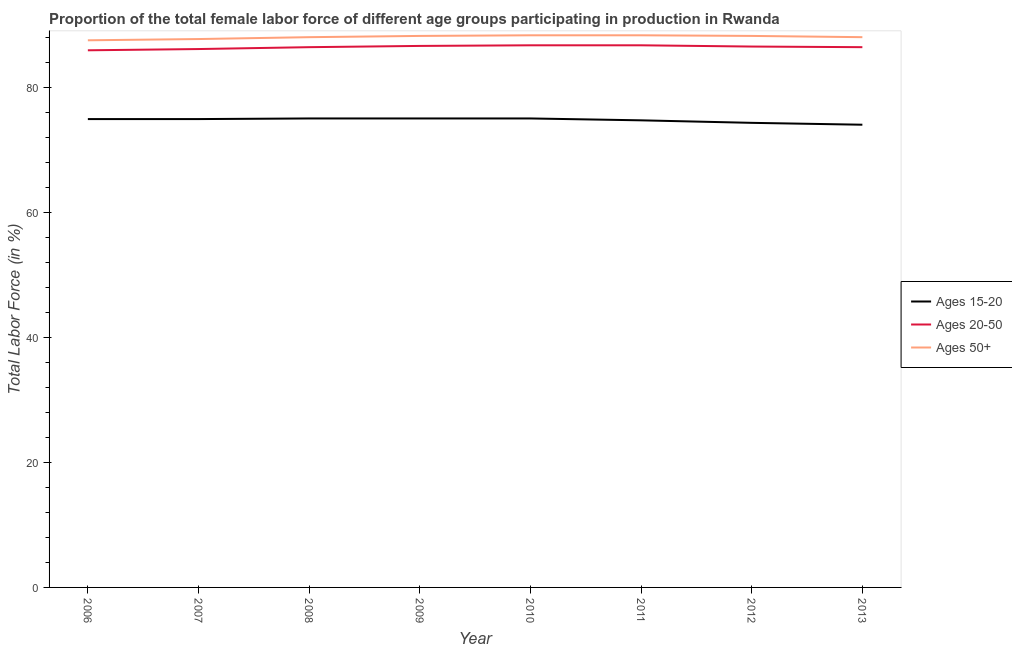Is the number of lines equal to the number of legend labels?
Provide a short and direct response. Yes. What is the percentage of female labor force within the age group 20-50 in 2009?
Ensure brevity in your answer.  86.6. Across all years, what is the maximum percentage of female labor force within the age group 20-50?
Your response must be concise. 86.7. Across all years, what is the minimum percentage of female labor force within the age group 15-20?
Your answer should be very brief. 74. What is the total percentage of female labor force within the age group 15-20 in the graph?
Ensure brevity in your answer.  597.8. What is the difference between the percentage of female labor force above age 50 in 2008 and that in 2011?
Your answer should be very brief. -0.3. What is the difference between the percentage of female labor force above age 50 in 2010 and the percentage of female labor force within the age group 20-50 in 2011?
Provide a succinct answer. 1.6. What is the average percentage of female labor force above age 50 per year?
Provide a succinct answer. 88.02. In the year 2007, what is the difference between the percentage of female labor force within the age group 15-20 and percentage of female labor force within the age group 20-50?
Your response must be concise. -11.2. In how many years, is the percentage of female labor force above age 50 greater than 16 %?
Your answer should be very brief. 8. What is the ratio of the percentage of female labor force above age 50 in 2012 to that in 2013?
Keep it short and to the point. 1. Is the percentage of female labor force within the age group 15-20 in 2006 less than that in 2012?
Provide a succinct answer. No. What is the difference between the highest and the second highest percentage of female labor force within the age group 15-20?
Your answer should be very brief. 0. What is the difference between the highest and the lowest percentage of female labor force within the age group 15-20?
Your answer should be compact. 1. Is it the case that in every year, the sum of the percentage of female labor force within the age group 15-20 and percentage of female labor force within the age group 20-50 is greater than the percentage of female labor force above age 50?
Provide a short and direct response. Yes. Is the percentage of female labor force within the age group 20-50 strictly greater than the percentage of female labor force within the age group 15-20 over the years?
Your response must be concise. Yes. How many years are there in the graph?
Make the answer very short. 8. Does the graph contain any zero values?
Offer a very short reply. No. Does the graph contain grids?
Ensure brevity in your answer.  No. Where does the legend appear in the graph?
Offer a terse response. Center right. How many legend labels are there?
Offer a terse response. 3. How are the legend labels stacked?
Provide a succinct answer. Vertical. What is the title of the graph?
Give a very brief answer. Proportion of the total female labor force of different age groups participating in production in Rwanda. What is the label or title of the X-axis?
Make the answer very short. Year. What is the label or title of the Y-axis?
Your response must be concise. Total Labor Force (in %). What is the Total Labor Force (in %) of Ages 15-20 in 2006?
Your answer should be very brief. 74.9. What is the Total Labor Force (in %) of Ages 20-50 in 2006?
Ensure brevity in your answer.  85.9. What is the Total Labor Force (in %) of Ages 50+ in 2006?
Keep it short and to the point. 87.5. What is the Total Labor Force (in %) in Ages 15-20 in 2007?
Ensure brevity in your answer.  74.9. What is the Total Labor Force (in %) of Ages 20-50 in 2007?
Ensure brevity in your answer.  86.1. What is the Total Labor Force (in %) of Ages 50+ in 2007?
Provide a short and direct response. 87.7. What is the Total Labor Force (in %) in Ages 15-20 in 2008?
Offer a terse response. 75. What is the Total Labor Force (in %) in Ages 20-50 in 2008?
Keep it short and to the point. 86.4. What is the Total Labor Force (in %) in Ages 20-50 in 2009?
Keep it short and to the point. 86.6. What is the Total Labor Force (in %) of Ages 50+ in 2009?
Keep it short and to the point. 88.2. What is the Total Labor Force (in %) in Ages 20-50 in 2010?
Offer a very short reply. 86.7. What is the Total Labor Force (in %) in Ages 50+ in 2010?
Give a very brief answer. 88.3. What is the Total Labor Force (in %) in Ages 15-20 in 2011?
Make the answer very short. 74.7. What is the Total Labor Force (in %) in Ages 20-50 in 2011?
Offer a very short reply. 86.7. What is the Total Labor Force (in %) in Ages 50+ in 2011?
Provide a short and direct response. 88.3. What is the Total Labor Force (in %) of Ages 15-20 in 2012?
Offer a terse response. 74.3. What is the Total Labor Force (in %) of Ages 20-50 in 2012?
Provide a succinct answer. 86.5. What is the Total Labor Force (in %) of Ages 50+ in 2012?
Keep it short and to the point. 88.2. What is the Total Labor Force (in %) in Ages 15-20 in 2013?
Provide a succinct answer. 74. What is the Total Labor Force (in %) of Ages 20-50 in 2013?
Offer a very short reply. 86.4. What is the Total Labor Force (in %) in Ages 50+ in 2013?
Provide a short and direct response. 88. Across all years, what is the maximum Total Labor Force (in %) in Ages 20-50?
Offer a terse response. 86.7. Across all years, what is the maximum Total Labor Force (in %) of Ages 50+?
Give a very brief answer. 88.3. Across all years, what is the minimum Total Labor Force (in %) in Ages 15-20?
Offer a very short reply. 74. Across all years, what is the minimum Total Labor Force (in %) of Ages 20-50?
Your response must be concise. 85.9. Across all years, what is the minimum Total Labor Force (in %) in Ages 50+?
Provide a short and direct response. 87.5. What is the total Total Labor Force (in %) in Ages 15-20 in the graph?
Provide a succinct answer. 597.8. What is the total Total Labor Force (in %) in Ages 20-50 in the graph?
Ensure brevity in your answer.  691.3. What is the total Total Labor Force (in %) of Ages 50+ in the graph?
Keep it short and to the point. 704.2. What is the difference between the Total Labor Force (in %) in Ages 15-20 in 2006 and that in 2009?
Make the answer very short. -0.1. What is the difference between the Total Labor Force (in %) in Ages 50+ in 2006 and that in 2009?
Offer a very short reply. -0.7. What is the difference between the Total Labor Force (in %) in Ages 20-50 in 2006 and that in 2010?
Offer a very short reply. -0.8. What is the difference between the Total Labor Force (in %) in Ages 50+ in 2006 and that in 2010?
Keep it short and to the point. -0.8. What is the difference between the Total Labor Force (in %) of Ages 50+ in 2006 and that in 2011?
Offer a very short reply. -0.8. What is the difference between the Total Labor Force (in %) in Ages 50+ in 2006 and that in 2012?
Your response must be concise. -0.7. What is the difference between the Total Labor Force (in %) of Ages 20-50 in 2006 and that in 2013?
Your answer should be compact. -0.5. What is the difference between the Total Labor Force (in %) in Ages 50+ in 2006 and that in 2013?
Give a very brief answer. -0.5. What is the difference between the Total Labor Force (in %) in Ages 20-50 in 2007 and that in 2008?
Offer a very short reply. -0.3. What is the difference between the Total Labor Force (in %) in Ages 50+ in 2007 and that in 2008?
Your response must be concise. -0.3. What is the difference between the Total Labor Force (in %) of Ages 20-50 in 2007 and that in 2009?
Make the answer very short. -0.5. What is the difference between the Total Labor Force (in %) in Ages 50+ in 2007 and that in 2009?
Your answer should be compact. -0.5. What is the difference between the Total Labor Force (in %) in Ages 15-20 in 2007 and that in 2010?
Your response must be concise. -0.1. What is the difference between the Total Labor Force (in %) in Ages 50+ in 2007 and that in 2010?
Give a very brief answer. -0.6. What is the difference between the Total Labor Force (in %) of Ages 15-20 in 2007 and that in 2011?
Your answer should be very brief. 0.2. What is the difference between the Total Labor Force (in %) in Ages 50+ in 2007 and that in 2011?
Offer a terse response. -0.6. What is the difference between the Total Labor Force (in %) in Ages 15-20 in 2007 and that in 2012?
Ensure brevity in your answer.  0.6. What is the difference between the Total Labor Force (in %) of Ages 50+ in 2007 and that in 2012?
Make the answer very short. -0.5. What is the difference between the Total Labor Force (in %) in Ages 15-20 in 2007 and that in 2013?
Give a very brief answer. 0.9. What is the difference between the Total Labor Force (in %) of Ages 15-20 in 2008 and that in 2009?
Make the answer very short. 0. What is the difference between the Total Labor Force (in %) in Ages 20-50 in 2008 and that in 2009?
Your response must be concise. -0.2. What is the difference between the Total Labor Force (in %) of Ages 50+ in 2008 and that in 2009?
Your answer should be compact. -0.2. What is the difference between the Total Labor Force (in %) in Ages 20-50 in 2008 and that in 2010?
Your answer should be compact. -0.3. What is the difference between the Total Labor Force (in %) in Ages 50+ in 2008 and that in 2010?
Ensure brevity in your answer.  -0.3. What is the difference between the Total Labor Force (in %) in Ages 15-20 in 2008 and that in 2011?
Ensure brevity in your answer.  0.3. What is the difference between the Total Labor Force (in %) in Ages 20-50 in 2008 and that in 2011?
Offer a terse response. -0.3. What is the difference between the Total Labor Force (in %) of Ages 15-20 in 2008 and that in 2012?
Keep it short and to the point. 0.7. What is the difference between the Total Labor Force (in %) in Ages 15-20 in 2008 and that in 2013?
Provide a short and direct response. 1. What is the difference between the Total Labor Force (in %) in Ages 15-20 in 2009 and that in 2010?
Your answer should be very brief. 0. What is the difference between the Total Labor Force (in %) of Ages 50+ in 2009 and that in 2010?
Provide a succinct answer. -0.1. What is the difference between the Total Labor Force (in %) of Ages 50+ in 2009 and that in 2011?
Give a very brief answer. -0.1. What is the difference between the Total Labor Force (in %) of Ages 15-20 in 2009 and that in 2012?
Your response must be concise. 0.7. What is the difference between the Total Labor Force (in %) in Ages 50+ in 2009 and that in 2013?
Offer a very short reply. 0.2. What is the difference between the Total Labor Force (in %) of Ages 15-20 in 2010 and that in 2011?
Your answer should be compact. 0.3. What is the difference between the Total Labor Force (in %) of Ages 50+ in 2010 and that in 2011?
Your answer should be very brief. 0. What is the difference between the Total Labor Force (in %) of Ages 15-20 in 2010 and that in 2012?
Your answer should be very brief. 0.7. What is the difference between the Total Labor Force (in %) in Ages 20-50 in 2010 and that in 2012?
Give a very brief answer. 0.2. What is the difference between the Total Labor Force (in %) in Ages 50+ in 2010 and that in 2012?
Your answer should be compact. 0.1. What is the difference between the Total Labor Force (in %) of Ages 15-20 in 2010 and that in 2013?
Ensure brevity in your answer.  1. What is the difference between the Total Labor Force (in %) of Ages 50+ in 2010 and that in 2013?
Provide a short and direct response. 0.3. What is the difference between the Total Labor Force (in %) of Ages 15-20 in 2011 and that in 2012?
Give a very brief answer. 0.4. What is the difference between the Total Labor Force (in %) of Ages 20-50 in 2011 and that in 2012?
Make the answer very short. 0.2. What is the difference between the Total Labor Force (in %) of Ages 50+ in 2011 and that in 2012?
Give a very brief answer. 0.1. What is the difference between the Total Labor Force (in %) of Ages 20-50 in 2011 and that in 2013?
Provide a succinct answer. 0.3. What is the difference between the Total Labor Force (in %) in Ages 50+ in 2012 and that in 2013?
Your response must be concise. 0.2. What is the difference between the Total Labor Force (in %) of Ages 15-20 in 2006 and the Total Labor Force (in %) of Ages 20-50 in 2008?
Your answer should be compact. -11.5. What is the difference between the Total Labor Force (in %) in Ages 20-50 in 2006 and the Total Labor Force (in %) in Ages 50+ in 2010?
Your answer should be very brief. -2.4. What is the difference between the Total Labor Force (in %) in Ages 15-20 in 2006 and the Total Labor Force (in %) in Ages 50+ in 2011?
Make the answer very short. -13.4. What is the difference between the Total Labor Force (in %) in Ages 15-20 in 2006 and the Total Labor Force (in %) in Ages 20-50 in 2012?
Your response must be concise. -11.6. What is the difference between the Total Labor Force (in %) of Ages 20-50 in 2006 and the Total Labor Force (in %) of Ages 50+ in 2012?
Offer a terse response. -2.3. What is the difference between the Total Labor Force (in %) of Ages 15-20 in 2006 and the Total Labor Force (in %) of Ages 20-50 in 2013?
Provide a short and direct response. -11.5. What is the difference between the Total Labor Force (in %) of Ages 20-50 in 2006 and the Total Labor Force (in %) of Ages 50+ in 2013?
Keep it short and to the point. -2.1. What is the difference between the Total Labor Force (in %) in Ages 15-20 in 2007 and the Total Labor Force (in %) in Ages 20-50 in 2008?
Provide a short and direct response. -11.5. What is the difference between the Total Labor Force (in %) of Ages 15-20 in 2007 and the Total Labor Force (in %) of Ages 50+ in 2008?
Offer a terse response. -13.1. What is the difference between the Total Labor Force (in %) of Ages 20-50 in 2007 and the Total Labor Force (in %) of Ages 50+ in 2008?
Ensure brevity in your answer.  -1.9. What is the difference between the Total Labor Force (in %) in Ages 15-20 in 2007 and the Total Labor Force (in %) in Ages 20-50 in 2009?
Your answer should be compact. -11.7. What is the difference between the Total Labor Force (in %) in Ages 15-20 in 2007 and the Total Labor Force (in %) in Ages 50+ in 2009?
Offer a very short reply. -13.3. What is the difference between the Total Labor Force (in %) in Ages 15-20 in 2007 and the Total Labor Force (in %) in Ages 20-50 in 2011?
Provide a succinct answer. -11.8. What is the difference between the Total Labor Force (in %) of Ages 15-20 in 2007 and the Total Labor Force (in %) of Ages 50+ in 2011?
Your answer should be compact. -13.4. What is the difference between the Total Labor Force (in %) of Ages 15-20 in 2007 and the Total Labor Force (in %) of Ages 20-50 in 2012?
Your answer should be compact. -11.6. What is the difference between the Total Labor Force (in %) in Ages 15-20 in 2007 and the Total Labor Force (in %) in Ages 50+ in 2013?
Offer a terse response. -13.1. What is the difference between the Total Labor Force (in %) in Ages 15-20 in 2008 and the Total Labor Force (in %) in Ages 50+ in 2009?
Keep it short and to the point. -13.2. What is the difference between the Total Labor Force (in %) of Ages 20-50 in 2008 and the Total Labor Force (in %) of Ages 50+ in 2009?
Your answer should be compact. -1.8. What is the difference between the Total Labor Force (in %) in Ages 15-20 in 2008 and the Total Labor Force (in %) in Ages 20-50 in 2010?
Your response must be concise. -11.7. What is the difference between the Total Labor Force (in %) in Ages 15-20 in 2008 and the Total Labor Force (in %) in Ages 50+ in 2011?
Keep it short and to the point. -13.3. What is the difference between the Total Labor Force (in %) of Ages 20-50 in 2008 and the Total Labor Force (in %) of Ages 50+ in 2011?
Make the answer very short. -1.9. What is the difference between the Total Labor Force (in %) in Ages 15-20 in 2008 and the Total Labor Force (in %) in Ages 20-50 in 2012?
Your response must be concise. -11.5. What is the difference between the Total Labor Force (in %) in Ages 20-50 in 2008 and the Total Labor Force (in %) in Ages 50+ in 2013?
Keep it short and to the point. -1.6. What is the difference between the Total Labor Force (in %) of Ages 15-20 in 2009 and the Total Labor Force (in %) of Ages 50+ in 2010?
Provide a succinct answer. -13.3. What is the difference between the Total Labor Force (in %) of Ages 15-20 in 2009 and the Total Labor Force (in %) of Ages 20-50 in 2011?
Provide a short and direct response. -11.7. What is the difference between the Total Labor Force (in %) of Ages 20-50 in 2009 and the Total Labor Force (in %) of Ages 50+ in 2011?
Your answer should be compact. -1.7. What is the difference between the Total Labor Force (in %) of Ages 20-50 in 2009 and the Total Labor Force (in %) of Ages 50+ in 2012?
Give a very brief answer. -1.6. What is the difference between the Total Labor Force (in %) of Ages 15-20 in 2009 and the Total Labor Force (in %) of Ages 50+ in 2013?
Make the answer very short. -13. What is the difference between the Total Labor Force (in %) of Ages 15-20 in 2010 and the Total Labor Force (in %) of Ages 50+ in 2011?
Your answer should be compact. -13.3. What is the difference between the Total Labor Force (in %) of Ages 15-20 in 2010 and the Total Labor Force (in %) of Ages 20-50 in 2012?
Keep it short and to the point. -11.5. What is the difference between the Total Labor Force (in %) of Ages 15-20 in 2010 and the Total Labor Force (in %) of Ages 50+ in 2013?
Make the answer very short. -13. What is the difference between the Total Labor Force (in %) in Ages 15-20 in 2011 and the Total Labor Force (in %) in Ages 50+ in 2012?
Make the answer very short. -13.5. What is the difference between the Total Labor Force (in %) of Ages 20-50 in 2011 and the Total Labor Force (in %) of Ages 50+ in 2012?
Offer a very short reply. -1.5. What is the difference between the Total Labor Force (in %) of Ages 15-20 in 2011 and the Total Labor Force (in %) of Ages 20-50 in 2013?
Give a very brief answer. -11.7. What is the difference between the Total Labor Force (in %) of Ages 15-20 in 2012 and the Total Labor Force (in %) of Ages 50+ in 2013?
Provide a succinct answer. -13.7. What is the difference between the Total Labor Force (in %) of Ages 20-50 in 2012 and the Total Labor Force (in %) of Ages 50+ in 2013?
Your response must be concise. -1.5. What is the average Total Labor Force (in %) in Ages 15-20 per year?
Give a very brief answer. 74.72. What is the average Total Labor Force (in %) in Ages 20-50 per year?
Give a very brief answer. 86.41. What is the average Total Labor Force (in %) of Ages 50+ per year?
Make the answer very short. 88.03. In the year 2006, what is the difference between the Total Labor Force (in %) in Ages 15-20 and Total Labor Force (in %) in Ages 50+?
Keep it short and to the point. -12.6. In the year 2008, what is the difference between the Total Labor Force (in %) in Ages 20-50 and Total Labor Force (in %) in Ages 50+?
Provide a short and direct response. -1.6. In the year 2009, what is the difference between the Total Labor Force (in %) in Ages 15-20 and Total Labor Force (in %) in Ages 20-50?
Your answer should be compact. -11.6. In the year 2009, what is the difference between the Total Labor Force (in %) of Ages 15-20 and Total Labor Force (in %) of Ages 50+?
Make the answer very short. -13.2. In the year 2010, what is the difference between the Total Labor Force (in %) in Ages 15-20 and Total Labor Force (in %) in Ages 20-50?
Your answer should be very brief. -11.7. In the year 2010, what is the difference between the Total Labor Force (in %) of Ages 20-50 and Total Labor Force (in %) of Ages 50+?
Give a very brief answer. -1.6. In the year 2011, what is the difference between the Total Labor Force (in %) of Ages 20-50 and Total Labor Force (in %) of Ages 50+?
Make the answer very short. -1.6. In the year 2012, what is the difference between the Total Labor Force (in %) in Ages 15-20 and Total Labor Force (in %) in Ages 50+?
Provide a succinct answer. -13.9. In the year 2012, what is the difference between the Total Labor Force (in %) of Ages 20-50 and Total Labor Force (in %) of Ages 50+?
Ensure brevity in your answer.  -1.7. In the year 2013, what is the difference between the Total Labor Force (in %) of Ages 20-50 and Total Labor Force (in %) of Ages 50+?
Offer a very short reply. -1.6. What is the ratio of the Total Labor Force (in %) of Ages 20-50 in 2006 to that in 2007?
Provide a short and direct response. 1. What is the ratio of the Total Labor Force (in %) in Ages 50+ in 2006 to that in 2007?
Your response must be concise. 1. What is the ratio of the Total Labor Force (in %) in Ages 50+ in 2006 to that in 2008?
Ensure brevity in your answer.  0.99. What is the ratio of the Total Labor Force (in %) of Ages 20-50 in 2006 to that in 2009?
Provide a succinct answer. 0.99. What is the ratio of the Total Labor Force (in %) of Ages 50+ in 2006 to that in 2010?
Offer a very short reply. 0.99. What is the ratio of the Total Labor Force (in %) of Ages 20-50 in 2006 to that in 2011?
Your answer should be very brief. 0.99. What is the ratio of the Total Labor Force (in %) in Ages 50+ in 2006 to that in 2011?
Your response must be concise. 0.99. What is the ratio of the Total Labor Force (in %) of Ages 20-50 in 2006 to that in 2012?
Offer a very short reply. 0.99. What is the ratio of the Total Labor Force (in %) in Ages 15-20 in 2006 to that in 2013?
Your response must be concise. 1.01. What is the ratio of the Total Labor Force (in %) of Ages 20-50 in 2006 to that in 2013?
Ensure brevity in your answer.  0.99. What is the ratio of the Total Labor Force (in %) of Ages 50+ in 2006 to that in 2013?
Your answer should be compact. 0.99. What is the ratio of the Total Labor Force (in %) in Ages 15-20 in 2007 to that in 2008?
Your answer should be very brief. 1. What is the ratio of the Total Labor Force (in %) in Ages 20-50 in 2007 to that in 2008?
Offer a very short reply. 1. What is the ratio of the Total Labor Force (in %) in Ages 20-50 in 2007 to that in 2010?
Offer a terse response. 0.99. What is the ratio of the Total Labor Force (in %) in Ages 15-20 in 2007 to that in 2011?
Provide a succinct answer. 1. What is the ratio of the Total Labor Force (in %) in Ages 20-50 in 2007 to that in 2012?
Provide a short and direct response. 1. What is the ratio of the Total Labor Force (in %) in Ages 15-20 in 2007 to that in 2013?
Provide a short and direct response. 1.01. What is the ratio of the Total Labor Force (in %) in Ages 20-50 in 2008 to that in 2009?
Ensure brevity in your answer.  1. What is the ratio of the Total Labor Force (in %) of Ages 50+ in 2008 to that in 2009?
Give a very brief answer. 1. What is the ratio of the Total Labor Force (in %) in Ages 15-20 in 2008 to that in 2011?
Ensure brevity in your answer.  1. What is the ratio of the Total Labor Force (in %) in Ages 20-50 in 2008 to that in 2011?
Your answer should be compact. 1. What is the ratio of the Total Labor Force (in %) in Ages 15-20 in 2008 to that in 2012?
Your answer should be very brief. 1.01. What is the ratio of the Total Labor Force (in %) of Ages 15-20 in 2008 to that in 2013?
Offer a very short reply. 1.01. What is the ratio of the Total Labor Force (in %) in Ages 20-50 in 2008 to that in 2013?
Offer a terse response. 1. What is the ratio of the Total Labor Force (in %) in Ages 50+ in 2008 to that in 2013?
Your answer should be very brief. 1. What is the ratio of the Total Labor Force (in %) in Ages 15-20 in 2009 to that in 2010?
Provide a succinct answer. 1. What is the ratio of the Total Labor Force (in %) of Ages 15-20 in 2009 to that in 2011?
Keep it short and to the point. 1. What is the ratio of the Total Labor Force (in %) of Ages 20-50 in 2009 to that in 2011?
Give a very brief answer. 1. What is the ratio of the Total Labor Force (in %) in Ages 50+ in 2009 to that in 2011?
Your answer should be very brief. 1. What is the ratio of the Total Labor Force (in %) of Ages 15-20 in 2009 to that in 2012?
Provide a short and direct response. 1.01. What is the ratio of the Total Labor Force (in %) of Ages 15-20 in 2009 to that in 2013?
Your answer should be very brief. 1.01. What is the ratio of the Total Labor Force (in %) in Ages 20-50 in 2010 to that in 2011?
Offer a terse response. 1. What is the ratio of the Total Labor Force (in %) in Ages 50+ in 2010 to that in 2011?
Provide a succinct answer. 1. What is the ratio of the Total Labor Force (in %) in Ages 15-20 in 2010 to that in 2012?
Your answer should be very brief. 1.01. What is the ratio of the Total Labor Force (in %) in Ages 50+ in 2010 to that in 2012?
Make the answer very short. 1. What is the ratio of the Total Labor Force (in %) of Ages 15-20 in 2010 to that in 2013?
Your response must be concise. 1.01. What is the ratio of the Total Labor Force (in %) in Ages 50+ in 2010 to that in 2013?
Your answer should be very brief. 1. What is the ratio of the Total Labor Force (in %) of Ages 15-20 in 2011 to that in 2012?
Your response must be concise. 1.01. What is the ratio of the Total Labor Force (in %) of Ages 15-20 in 2011 to that in 2013?
Provide a short and direct response. 1.01. What is the ratio of the Total Labor Force (in %) in Ages 20-50 in 2011 to that in 2013?
Your answer should be very brief. 1. What is the ratio of the Total Labor Force (in %) in Ages 50+ in 2011 to that in 2013?
Your answer should be very brief. 1. What is the difference between the highest and the second highest Total Labor Force (in %) in Ages 15-20?
Ensure brevity in your answer.  0. What is the difference between the highest and the lowest Total Labor Force (in %) of Ages 15-20?
Offer a terse response. 1. What is the difference between the highest and the lowest Total Labor Force (in %) of Ages 50+?
Make the answer very short. 0.8. 